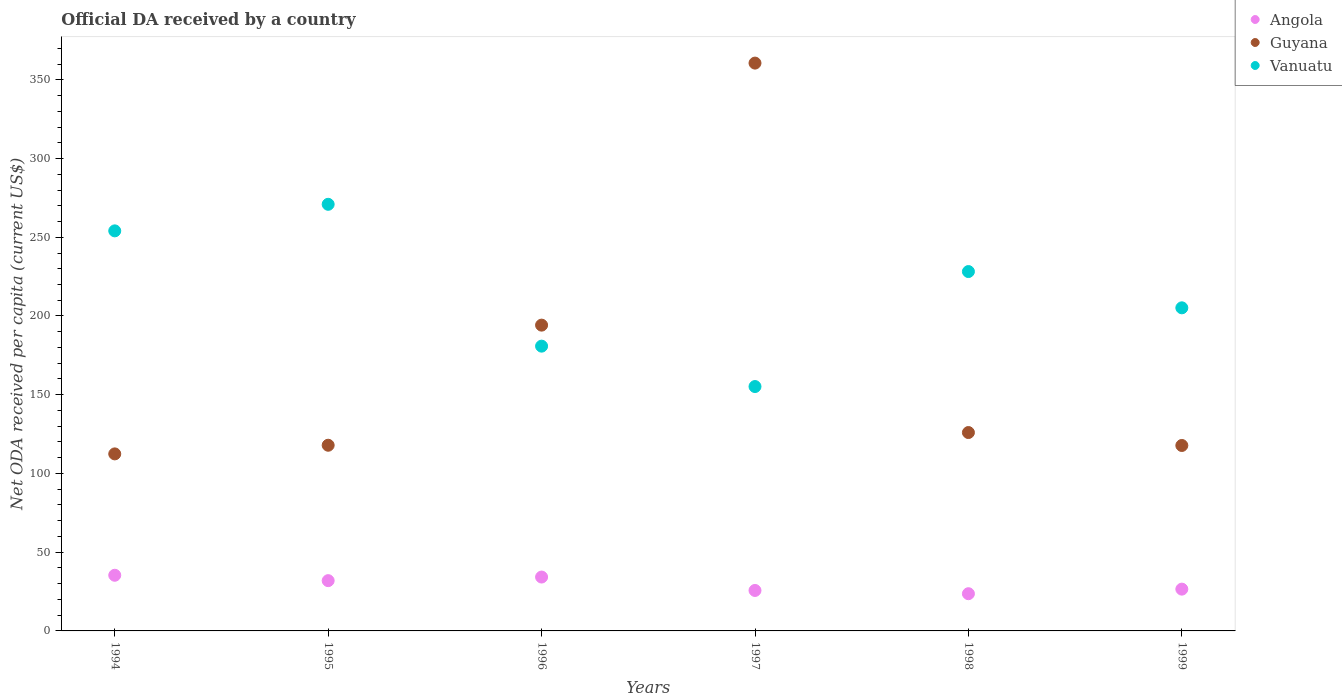What is the ODA received in in Vanuatu in 1997?
Your answer should be very brief. 155.2. Across all years, what is the maximum ODA received in in Vanuatu?
Offer a very short reply. 270.93. Across all years, what is the minimum ODA received in in Guyana?
Keep it short and to the point. 112.43. In which year was the ODA received in in Vanuatu minimum?
Your response must be concise. 1997. What is the total ODA received in in Angola in the graph?
Your answer should be compact. 177.35. What is the difference between the ODA received in in Vanuatu in 1994 and that in 1995?
Ensure brevity in your answer.  -16.86. What is the difference between the ODA received in in Angola in 1998 and the ODA received in in Vanuatu in 1995?
Your response must be concise. -247.3. What is the average ODA received in in Vanuatu per year?
Offer a very short reply. 215.74. In the year 1999, what is the difference between the ODA received in in Angola and ODA received in in Guyana?
Ensure brevity in your answer.  -91.23. In how many years, is the ODA received in in Guyana greater than 110 US$?
Your answer should be very brief. 6. What is the ratio of the ODA received in in Guyana in 1994 to that in 1997?
Provide a short and direct response. 0.31. Is the ODA received in in Angola in 1997 less than that in 1998?
Give a very brief answer. No. Is the difference between the ODA received in in Angola in 1996 and 1997 greater than the difference between the ODA received in in Guyana in 1996 and 1997?
Keep it short and to the point. Yes. What is the difference between the highest and the second highest ODA received in in Vanuatu?
Make the answer very short. 16.86. What is the difference between the highest and the lowest ODA received in in Vanuatu?
Offer a terse response. 115.73. In how many years, is the ODA received in in Guyana greater than the average ODA received in in Guyana taken over all years?
Ensure brevity in your answer.  2. Is the sum of the ODA received in in Guyana in 1994 and 1996 greater than the maximum ODA received in in Angola across all years?
Make the answer very short. Yes. Is it the case that in every year, the sum of the ODA received in in Guyana and ODA received in in Angola  is greater than the ODA received in in Vanuatu?
Give a very brief answer. No. Is the ODA received in in Angola strictly less than the ODA received in in Guyana over the years?
Make the answer very short. Yes. How many dotlines are there?
Provide a short and direct response. 3. Are the values on the major ticks of Y-axis written in scientific E-notation?
Give a very brief answer. No. Where does the legend appear in the graph?
Your answer should be very brief. Top right. What is the title of the graph?
Give a very brief answer. Official DA received by a country. Does "Austria" appear as one of the legend labels in the graph?
Give a very brief answer. No. What is the label or title of the X-axis?
Your answer should be compact. Years. What is the label or title of the Y-axis?
Ensure brevity in your answer.  Net ODA received per capita (current US$). What is the Net ODA received per capita (current US$) of Angola in 1994?
Offer a very short reply. 35.35. What is the Net ODA received per capita (current US$) of Guyana in 1994?
Keep it short and to the point. 112.43. What is the Net ODA received per capita (current US$) of Vanuatu in 1994?
Make the answer very short. 254.07. What is the Net ODA received per capita (current US$) of Angola in 1995?
Make the answer very short. 31.93. What is the Net ODA received per capita (current US$) of Guyana in 1995?
Provide a succinct answer. 117.92. What is the Net ODA received per capita (current US$) in Vanuatu in 1995?
Keep it short and to the point. 270.93. What is the Net ODA received per capita (current US$) of Angola in 1996?
Ensure brevity in your answer.  34.21. What is the Net ODA received per capita (current US$) in Guyana in 1996?
Offer a very short reply. 194.2. What is the Net ODA received per capita (current US$) in Vanuatu in 1996?
Keep it short and to the point. 180.85. What is the Net ODA received per capita (current US$) of Angola in 1997?
Make the answer very short. 25.7. What is the Net ODA received per capita (current US$) in Guyana in 1997?
Your answer should be compact. 360.6. What is the Net ODA received per capita (current US$) of Vanuatu in 1997?
Make the answer very short. 155.2. What is the Net ODA received per capita (current US$) of Angola in 1998?
Give a very brief answer. 23.63. What is the Net ODA received per capita (current US$) in Guyana in 1998?
Make the answer very short. 125.98. What is the Net ODA received per capita (current US$) in Vanuatu in 1998?
Give a very brief answer. 228.22. What is the Net ODA received per capita (current US$) of Angola in 1999?
Offer a terse response. 26.54. What is the Net ODA received per capita (current US$) of Guyana in 1999?
Offer a terse response. 117.77. What is the Net ODA received per capita (current US$) in Vanuatu in 1999?
Offer a very short reply. 205.19. Across all years, what is the maximum Net ODA received per capita (current US$) of Angola?
Offer a terse response. 35.35. Across all years, what is the maximum Net ODA received per capita (current US$) of Guyana?
Offer a terse response. 360.6. Across all years, what is the maximum Net ODA received per capita (current US$) in Vanuatu?
Offer a terse response. 270.93. Across all years, what is the minimum Net ODA received per capita (current US$) in Angola?
Give a very brief answer. 23.63. Across all years, what is the minimum Net ODA received per capita (current US$) of Guyana?
Your answer should be compact. 112.43. Across all years, what is the minimum Net ODA received per capita (current US$) of Vanuatu?
Your answer should be compact. 155.2. What is the total Net ODA received per capita (current US$) of Angola in the graph?
Provide a short and direct response. 177.35. What is the total Net ODA received per capita (current US$) in Guyana in the graph?
Your response must be concise. 1028.89. What is the total Net ODA received per capita (current US$) of Vanuatu in the graph?
Keep it short and to the point. 1294.45. What is the difference between the Net ODA received per capita (current US$) in Angola in 1994 and that in 1995?
Your answer should be compact. 3.42. What is the difference between the Net ODA received per capita (current US$) of Guyana in 1994 and that in 1995?
Keep it short and to the point. -5.49. What is the difference between the Net ODA received per capita (current US$) in Vanuatu in 1994 and that in 1995?
Keep it short and to the point. -16.86. What is the difference between the Net ODA received per capita (current US$) in Angola in 1994 and that in 1996?
Ensure brevity in your answer.  1.13. What is the difference between the Net ODA received per capita (current US$) in Guyana in 1994 and that in 1996?
Ensure brevity in your answer.  -81.77. What is the difference between the Net ODA received per capita (current US$) in Vanuatu in 1994 and that in 1996?
Provide a succinct answer. 73.22. What is the difference between the Net ODA received per capita (current US$) in Angola in 1994 and that in 1997?
Your answer should be compact. 9.65. What is the difference between the Net ODA received per capita (current US$) in Guyana in 1994 and that in 1997?
Provide a short and direct response. -248.18. What is the difference between the Net ODA received per capita (current US$) of Vanuatu in 1994 and that in 1997?
Provide a succinct answer. 98.87. What is the difference between the Net ODA received per capita (current US$) of Angola in 1994 and that in 1998?
Give a very brief answer. 11.71. What is the difference between the Net ODA received per capita (current US$) of Guyana in 1994 and that in 1998?
Keep it short and to the point. -13.56. What is the difference between the Net ODA received per capita (current US$) of Vanuatu in 1994 and that in 1998?
Make the answer very short. 25.85. What is the difference between the Net ODA received per capita (current US$) of Angola in 1994 and that in 1999?
Offer a terse response. 8.81. What is the difference between the Net ODA received per capita (current US$) of Guyana in 1994 and that in 1999?
Offer a very short reply. -5.34. What is the difference between the Net ODA received per capita (current US$) in Vanuatu in 1994 and that in 1999?
Ensure brevity in your answer.  48.88. What is the difference between the Net ODA received per capita (current US$) in Angola in 1995 and that in 1996?
Give a very brief answer. -2.29. What is the difference between the Net ODA received per capita (current US$) in Guyana in 1995 and that in 1996?
Provide a succinct answer. -76.28. What is the difference between the Net ODA received per capita (current US$) in Vanuatu in 1995 and that in 1996?
Your answer should be compact. 90.08. What is the difference between the Net ODA received per capita (current US$) in Angola in 1995 and that in 1997?
Offer a terse response. 6.23. What is the difference between the Net ODA received per capita (current US$) in Guyana in 1995 and that in 1997?
Offer a terse response. -242.69. What is the difference between the Net ODA received per capita (current US$) of Vanuatu in 1995 and that in 1997?
Your answer should be very brief. 115.73. What is the difference between the Net ODA received per capita (current US$) in Angola in 1995 and that in 1998?
Keep it short and to the point. 8.3. What is the difference between the Net ODA received per capita (current US$) of Guyana in 1995 and that in 1998?
Your answer should be compact. -8.07. What is the difference between the Net ODA received per capita (current US$) in Vanuatu in 1995 and that in 1998?
Give a very brief answer. 42.71. What is the difference between the Net ODA received per capita (current US$) in Angola in 1995 and that in 1999?
Your answer should be very brief. 5.39. What is the difference between the Net ODA received per capita (current US$) in Guyana in 1995 and that in 1999?
Keep it short and to the point. 0.15. What is the difference between the Net ODA received per capita (current US$) in Vanuatu in 1995 and that in 1999?
Ensure brevity in your answer.  65.74. What is the difference between the Net ODA received per capita (current US$) in Angola in 1996 and that in 1997?
Provide a short and direct response. 8.52. What is the difference between the Net ODA received per capita (current US$) in Guyana in 1996 and that in 1997?
Offer a terse response. -166.41. What is the difference between the Net ODA received per capita (current US$) in Vanuatu in 1996 and that in 1997?
Ensure brevity in your answer.  25.65. What is the difference between the Net ODA received per capita (current US$) in Angola in 1996 and that in 1998?
Your answer should be very brief. 10.58. What is the difference between the Net ODA received per capita (current US$) in Guyana in 1996 and that in 1998?
Keep it short and to the point. 68.21. What is the difference between the Net ODA received per capita (current US$) of Vanuatu in 1996 and that in 1998?
Keep it short and to the point. -47.37. What is the difference between the Net ODA received per capita (current US$) in Angola in 1996 and that in 1999?
Give a very brief answer. 7.67. What is the difference between the Net ODA received per capita (current US$) of Guyana in 1996 and that in 1999?
Provide a succinct answer. 76.43. What is the difference between the Net ODA received per capita (current US$) in Vanuatu in 1996 and that in 1999?
Your response must be concise. -24.34. What is the difference between the Net ODA received per capita (current US$) in Angola in 1997 and that in 1998?
Make the answer very short. 2.07. What is the difference between the Net ODA received per capita (current US$) of Guyana in 1997 and that in 1998?
Provide a succinct answer. 234.62. What is the difference between the Net ODA received per capita (current US$) of Vanuatu in 1997 and that in 1998?
Offer a very short reply. -73.02. What is the difference between the Net ODA received per capita (current US$) of Angola in 1997 and that in 1999?
Your answer should be compact. -0.84. What is the difference between the Net ODA received per capita (current US$) in Guyana in 1997 and that in 1999?
Give a very brief answer. 242.84. What is the difference between the Net ODA received per capita (current US$) in Vanuatu in 1997 and that in 1999?
Ensure brevity in your answer.  -49.99. What is the difference between the Net ODA received per capita (current US$) in Angola in 1998 and that in 1999?
Your response must be concise. -2.91. What is the difference between the Net ODA received per capita (current US$) of Guyana in 1998 and that in 1999?
Provide a succinct answer. 8.22. What is the difference between the Net ODA received per capita (current US$) of Vanuatu in 1998 and that in 1999?
Your answer should be compact. 23.03. What is the difference between the Net ODA received per capita (current US$) of Angola in 1994 and the Net ODA received per capita (current US$) of Guyana in 1995?
Provide a short and direct response. -82.57. What is the difference between the Net ODA received per capita (current US$) in Angola in 1994 and the Net ODA received per capita (current US$) in Vanuatu in 1995?
Provide a short and direct response. -235.58. What is the difference between the Net ODA received per capita (current US$) of Guyana in 1994 and the Net ODA received per capita (current US$) of Vanuatu in 1995?
Offer a very short reply. -158.5. What is the difference between the Net ODA received per capita (current US$) in Angola in 1994 and the Net ODA received per capita (current US$) in Guyana in 1996?
Keep it short and to the point. -158.85. What is the difference between the Net ODA received per capita (current US$) in Angola in 1994 and the Net ODA received per capita (current US$) in Vanuatu in 1996?
Keep it short and to the point. -145.5. What is the difference between the Net ODA received per capita (current US$) in Guyana in 1994 and the Net ODA received per capita (current US$) in Vanuatu in 1996?
Your response must be concise. -68.42. What is the difference between the Net ODA received per capita (current US$) in Angola in 1994 and the Net ODA received per capita (current US$) in Guyana in 1997?
Your answer should be compact. -325.26. What is the difference between the Net ODA received per capita (current US$) in Angola in 1994 and the Net ODA received per capita (current US$) in Vanuatu in 1997?
Provide a succinct answer. -119.85. What is the difference between the Net ODA received per capita (current US$) of Guyana in 1994 and the Net ODA received per capita (current US$) of Vanuatu in 1997?
Your answer should be very brief. -42.77. What is the difference between the Net ODA received per capita (current US$) of Angola in 1994 and the Net ODA received per capita (current US$) of Guyana in 1998?
Make the answer very short. -90.64. What is the difference between the Net ODA received per capita (current US$) of Angola in 1994 and the Net ODA received per capita (current US$) of Vanuatu in 1998?
Keep it short and to the point. -192.87. What is the difference between the Net ODA received per capita (current US$) of Guyana in 1994 and the Net ODA received per capita (current US$) of Vanuatu in 1998?
Make the answer very short. -115.79. What is the difference between the Net ODA received per capita (current US$) in Angola in 1994 and the Net ODA received per capita (current US$) in Guyana in 1999?
Your answer should be very brief. -82.42. What is the difference between the Net ODA received per capita (current US$) of Angola in 1994 and the Net ODA received per capita (current US$) of Vanuatu in 1999?
Your response must be concise. -169.84. What is the difference between the Net ODA received per capita (current US$) of Guyana in 1994 and the Net ODA received per capita (current US$) of Vanuatu in 1999?
Provide a short and direct response. -92.76. What is the difference between the Net ODA received per capita (current US$) in Angola in 1995 and the Net ODA received per capita (current US$) in Guyana in 1996?
Offer a very short reply. -162.27. What is the difference between the Net ODA received per capita (current US$) of Angola in 1995 and the Net ODA received per capita (current US$) of Vanuatu in 1996?
Your answer should be very brief. -148.92. What is the difference between the Net ODA received per capita (current US$) of Guyana in 1995 and the Net ODA received per capita (current US$) of Vanuatu in 1996?
Keep it short and to the point. -62.93. What is the difference between the Net ODA received per capita (current US$) in Angola in 1995 and the Net ODA received per capita (current US$) in Guyana in 1997?
Give a very brief answer. -328.68. What is the difference between the Net ODA received per capita (current US$) of Angola in 1995 and the Net ODA received per capita (current US$) of Vanuatu in 1997?
Your answer should be compact. -123.27. What is the difference between the Net ODA received per capita (current US$) in Guyana in 1995 and the Net ODA received per capita (current US$) in Vanuatu in 1997?
Offer a terse response. -37.28. What is the difference between the Net ODA received per capita (current US$) in Angola in 1995 and the Net ODA received per capita (current US$) in Guyana in 1998?
Give a very brief answer. -94.06. What is the difference between the Net ODA received per capita (current US$) of Angola in 1995 and the Net ODA received per capita (current US$) of Vanuatu in 1998?
Provide a succinct answer. -196.29. What is the difference between the Net ODA received per capita (current US$) in Guyana in 1995 and the Net ODA received per capita (current US$) in Vanuatu in 1998?
Offer a very short reply. -110.3. What is the difference between the Net ODA received per capita (current US$) of Angola in 1995 and the Net ODA received per capita (current US$) of Guyana in 1999?
Offer a very short reply. -85.84. What is the difference between the Net ODA received per capita (current US$) in Angola in 1995 and the Net ODA received per capita (current US$) in Vanuatu in 1999?
Your answer should be very brief. -173.26. What is the difference between the Net ODA received per capita (current US$) in Guyana in 1995 and the Net ODA received per capita (current US$) in Vanuatu in 1999?
Keep it short and to the point. -87.27. What is the difference between the Net ODA received per capita (current US$) of Angola in 1996 and the Net ODA received per capita (current US$) of Guyana in 1997?
Provide a succinct answer. -326.39. What is the difference between the Net ODA received per capita (current US$) of Angola in 1996 and the Net ODA received per capita (current US$) of Vanuatu in 1997?
Your response must be concise. -120.98. What is the difference between the Net ODA received per capita (current US$) of Guyana in 1996 and the Net ODA received per capita (current US$) of Vanuatu in 1997?
Offer a very short reply. 39. What is the difference between the Net ODA received per capita (current US$) in Angola in 1996 and the Net ODA received per capita (current US$) in Guyana in 1998?
Give a very brief answer. -91.77. What is the difference between the Net ODA received per capita (current US$) in Angola in 1996 and the Net ODA received per capita (current US$) in Vanuatu in 1998?
Your response must be concise. -194.01. What is the difference between the Net ODA received per capita (current US$) of Guyana in 1996 and the Net ODA received per capita (current US$) of Vanuatu in 1998?
Make the answer very short. -34.02. What is the difference between the Net ODA received per capita (current US$) in Angola in 1996 and the Net ODA received per capita (current US$) in Guyana in 1999?
Your answer should be compact. -83.55. What is the difference between the Net ODA received per capita (current US$) of Angola in 1996 and the Net ODA received per capita (current US$) of Vanuatu in 1999?
Provide a succinct answer. -170.97. What is the difference between the Net ODA received per capita (current US$) in Guyana in 1996 and the Net ODA received per capita (current US$) in Vanuatu in 1999?
Offer a very short reply. -10.99. What is the difference between the Net ODA received per capita (current US$) in Angola in 1997 and the Net ODA received per capita (current US$) in Guyana in 1998?
Offer a very short reply. -100.29. What is the difference between the Net ODA received per capita (current US$) of Angola in 1997 and the Net ODA received per capita (current US$) of Vanuatu in 1998?
Your answer should be very brief. -202.52. What is the difference between the Net ODA received per capita (current US$) of Guyana in 1997 and the Net ODA received per capita (current US$) of Vanuatu in 1998?
Provide a short and direct response. 132.38. What is the difference between the Net ODA received per capita (current US$) of Angola in 1997 and the Net ODA received per capita (current US$) of Guyana in 1999?
Provide a succinct answer. -92.07. What is the difference between the Net ODA received per capita (current US$) of Angola in 1997 and the Net ODA received per capita (current US$) of Vanuatu in 1999?
Your answer should be compact. -179.49. What is the difference between the Net ODA received per capita (current US$) of Guyana in 1997 and the Net ODA received per capita (current US$) of Vanuatu in 1999?
Provide a short and direct response. 155.42. What is the difference between the Net ODA received per capita (current US$) of Angola in 1998 and the Net ODA received per capita (current US$) of Guyana in 1999?
Provide a short and direct response. -94.14. What is the difference between the Net ODA received per capita (current US$) of Angola in 1998 and the Net ODA received per capita (current US$) of Vanuatu in 1999?
Offer a terse response. -181.56. What is the difference between the Net ODA received per capita (current US$) in Guyana in 1998 and the Net ODA received per capita (current US$) in Vanuatu in 1999?
Make the answer very short. -79.2. What is the average Net ODA received per capita (current US$) of Angola per year?
Provide a short and direct response. 29.56. What is the average Net ODA received per capita (current US$) of Guyana per year?
Your answer should be very brief. 171.48. What is the average Net ODA received per capita (current US$) of Vanuatu per year?
Offer a very short reply. 215.74. In the year 1994, what is the difference between the Net ODA received per capita (current US$) in Angola and Net ODA received per capita (current US$) in Guyana?
Your answer should be very brief. -77.08. In the year 1994, what is the difference between the Net ODA received per capita (current US$) of Angola and Net ODA received per capita (current US$) of Vanuatu?
Keep it short and to the point. -218.72. In the year 1994, what is the difference between the Net ODA received per capita (current US$) in Guyana and Net ODA received per capita (current US$) in Vanuatu?
Your response must be concise. -141.64. In the year 1995, what is the difference between the Net ODA received per capita (current US$) of Angola and Net ODA received per capita (current US$) of Guyana?
Keep it short and to the point. -85.99. In the year 1995, what is the difference between the Net ODA received per capita (current US$) in Angola and Net ODA received per capita (current US$) in Vanuatu?
Keep it short and to the point. -239. In the year 1995, what is the difference between the Net ODA received per capita (current US$) of Guyana and Net ODA received per capita (current US$) of Vanuatu?
Provide a succinct answer. -153.01. In the year 1996, what is the difference between the Net ODA received per capita (current US$) of Angola and Net ODA received per capita (current US$) of Guyana?
Your response must be concise. -159.98. In the year 1996, what is the difference between the Net ODA received per capita (current US$) of Angola and Net ODA received per capita (current US$) of Vanuatu?
Provide a succinct answer. -146.63. In the year 1996, what is the difference between the Net ODA received per capita (current US$) of Guyana and Net ODA received per capita (current US$) of Vanuatu?
Offer a very short reply. 13.35. In the year 1997, what is the difference between the Net ODA received per capita (current US$) in Angola and Net ODA received per capita (current US$) in Guyana?
Provide a short and direct response. -334.91. In the year 1997, what is the difference between the Net ODA received per capita (current US$) of Angola and Net ODA received per capita (current US$) of Vanuatu?
Make the answer very short. -129.5. In the year 1997, what is the difference between the Net ODA received per capita (current US$) in Guyana and Net ODA received per capita (current US$) in Vanuatu?
Provide a succinct answer. 205.41. In the year 1998, what is the difference between the Net ODA received per capita (current US$) of Angola and Net ODA received per capita (current US$) of Guyana?
Your answer should be compact. -102.35. In the year 1998, what is the difference between the Net ODA received per capita (current US$) of Angola and Net ODA received per capita (current US$) of Vanuatu?
Give a very brief answer. -204.59. In the year 1998, what is the difference between the Net ODA received per capita (current US$) of Guyana and Net ODA received per capita (current US$) of Vanuatu?
Keep it short and to the point. -102.24. In the year 1999, what is the difference between the Net ODA received per capita (current US$) in Angola and Net ODA received per capita (current US$) in Guyana?
Provide a succinct answer. -91.23. In the year 1999, what is the difference between the Net ODA received per capita (current US$) in Angola and Net ODA received per capita (current US$) in Vanuatu?
Keep it short and to the point. -178.65. In the year 1999, what is the difference between the Net ODA received per capita (current US$) in Guyana and Net ODA received per capita (current US$) in Vanuatu?
Make the answer very short. -87.42. What is the ratio of the Net ODA received per capita (current US$) in Angola in 1994 to that in 1995?
Offer a very short reply. 1.11. What is the ratio of the Net ODA received per capita (current US$) in Guyana in 1994 to that in 1995?
Keep it short and to the point. 0.95. What is the ratio of the Net ODA received per capita (current US$) in Vanuatu in 1994 to that in 1995?
Provide a succinct answer. 0.94. What is the ratio of the Net ODA received per capita (current US$) of Angola in 1994 to that in 1996?
Your response must be concise. 1.03. What is the ratio of the Net ODA received per capita (current US$) in Guyana in 1994 to that in 1996?
Provide a succinct answer. 0.58. What is the ratio of the Net ODA received per capita (current US$) in Vanuatu in 1994 to that in 1996?
Provide a short and direct response. 1.4. What is the ratio of the Net ODA received per capita (current US$) in Angola in 1994 to that in 1997?
Offer a terse response. 1.38. What is the ratio of the Net ODA received per capita (current US$) in Guyana in 1994 to that in 1997?
Your answer should be very brief. 0.31. What is the ratio of the Net ODA received per capita (current US$) in Vanuatu in 1994 to that in 1997?
Your answer should be very brief. 1.64. What is the ratio of the Net ODA received per capita (current US$) of Angola in 1994 to that in 1998?
Offer a very short reply. 1.5. What is the ratio of the Net ODA received per capita (current US$) of Guyana in 1994 to that in 1998?
Your response must be concise. 0.89. What is the ratio of the Net ODA received per capita (current US$) of Vanuatu in 1994 to that in 1998?
Provide a short and direct response. 1.11. What is the ratio of the Net ODA received per capita (current US$) of Angola in 1994 to that in 1999?
Your answer should be compact. 1.33. What is the ratio of the Net ODA received per capita (current US$) of Guyana in 1994 to that in 1999?
Make the answer very short. 0.95. What is the ratio of the Net ODA received per capita (current US$) of Vanuatu in 1994 to that in 1999?
Offer a terse response. 1.24. What is the ratio of the Net ODA received per capita (current US$) of Angola in 1995 to that in 1996?
Offer a terse response. 0.93. What is the ratio of the Net ODA received per capita (current US$) in Guyana in 1995 to that in 1996?
Make the answer very short. 0.61. What is the ratio of the Net ODA received per capita (current US$) in Vanuatu in 1995 to that in 1996?
Offer a terse response. 1.5. What is the ratio of the Net ODA received per capita (current US$) in Angola in 1995 to that in 1997?
Make the answer very short. 1.24. What is the ratio of the Net ODA received per capita (current US$) in Guyana in 1995 to that in 1997?
Your answer should be compact. 0.33. What is the ratio of the Net ODA received per capita (current US$) of Vanuatu in 1995 to that in 1997?
Ensure brevity in your answer.  1.75. What is the ratio of the Net ODA received per capita (current US$) in Angola in 1995 to that in 1998?
Keep it short and to the point. 1.35. What is the ratio of the Net ODA received per capita (current US$) of Guyana in 1995 to that in 1998?
Give a very brief answer. 0.94. What is the ratio of the Net ODA received per capita (current US$) in Vanuatu in 1995 to that in 1998?
Offer a terse response. 1.19. What is the ratio of the Net ODA received per capita (current US$) in Angola in 1995 to that in 1999?
Offer a terse response. 1.2. What is the ratio of the Net ODA received per capita (current US$) of Vanuatu in 1995 to that in 1999?
Your response must be concise. 1.32. What is the ratio of the Net ODA received per capita (current US$) of Angola in 1996 to that in 1997?
Your response must be concise. 1.33. What is the ratio of the Net ODA received per capita (current US$) in Guyana in 1996 to that in 1997?
Provide a short and direct response. 0.54. What is the ratio of the Net ODA received per capita (current US$) of Vanuatu in 1996 to that in 1997?
Your answer should be very brief. 1.17. What is the ratio of the Net ODA received per capita (current US$) of Angola in 1996 to that in 1998?
Make the answer very short. 1.45. What is the ratio of the Net ODA received per capita (current US$) of Guyana in 1996 to that in 1998?
Provide a short and direct response. 1.54. What is the ratio of the Net ODA received per capita (current US$) of Vanuatu in 1996 to that in 1998?
Ensure brevity in your answer.  0.79. What is the ratio of the Net ODA received per capita (current US$) of Angola in 1996 to that in 1999?
Make the answer very short. 1.29. What is the ratio of the Net ODA received per capita (current US$) of Guyana in 1996 to that in 1999?
Your response must be concise. 1.65. What is the ratio of the Net ODA received per capita (current US$) of Vanuatu in 1996 to that in 1999?
Your answer should be very brief. 0.88. What is the ratio of the Net ODA received per capita (current US$) in Angola in 1997 to that in 1998?
Make the answer very short. 1.09. What is the ratio of the Net ODA received per capita (current US$) of Guyana in 1997 to that in 1998?
Give a very brief answer. 2.86. What is the ratio of the Net ODA received per capita (current US$) in Vanuatu in 1997 to that in 1998?
Offer a terse response. 0.68. What is the ratio of the Net ODA received per capita (current US$) in Angola in 1997 to that in 1999?
Provide a succinct answer. 0.97. What is the ratio of the Net ODA received per capita (current US$) of Guyana in 1997 to that in 1999?
Your response must be concise. 3.06. What is the ratio of the Net ODA received per capita (current US$) of Vanuatu in 1997 to that in 1999?
Your answer should be compact. 0.76. What is the ratio of the Net ODA received per capita (current US$) of Angola in 1998 to that in 1999?
Make the answer very short. 0.89. What is the ratio of the Net ODA received per capita (current US$) of Guyana in 1998 to that in 1999?
Make the answer very short. 1.07. What is the ratio of the Net ODA received per capita (current US$) in Vanuatu in 1998 to that in 1999?
Offer a terse response. 1.11. What is the difference between the highest and the second highest Net ODA received per capita (current US$) of Angola?
Offer a terse response. 1.13. What is the difference between the highest and the second highest Net ODA received per capita (current US$) of Guyana?
Offer a very short reply. 166.41. What is the difference between the highest and the second highest Net ODA received per capita (current US$) of Vanuatu?
Your response must be concise. 16.86. What is the difference between the highest and the lowest Net ODA received per capita (current US$) of Angola?
Provide a short and direct response. 11.71. What is the difference between the highest and the lowest Net ODA received per capita (current US$) in Guyana?
Your answer should be compact. 248.18. What is the difference between the highest and the lowest Net ODA received per capita (current US$) of Vanuatu?
Provide a succinct answer. 115.73. 